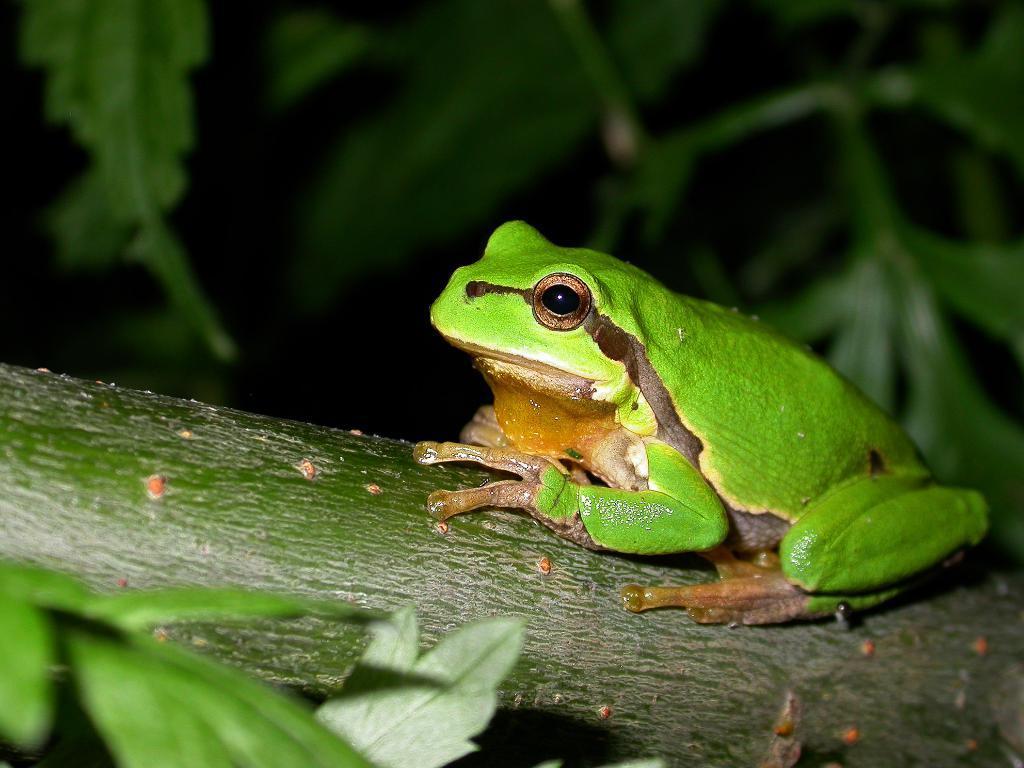Could you give a brief overview of what you see in this image? In this image we can see a frog and a branch. On the left side of the image there are leaves. In the background of the image there are leaves. 